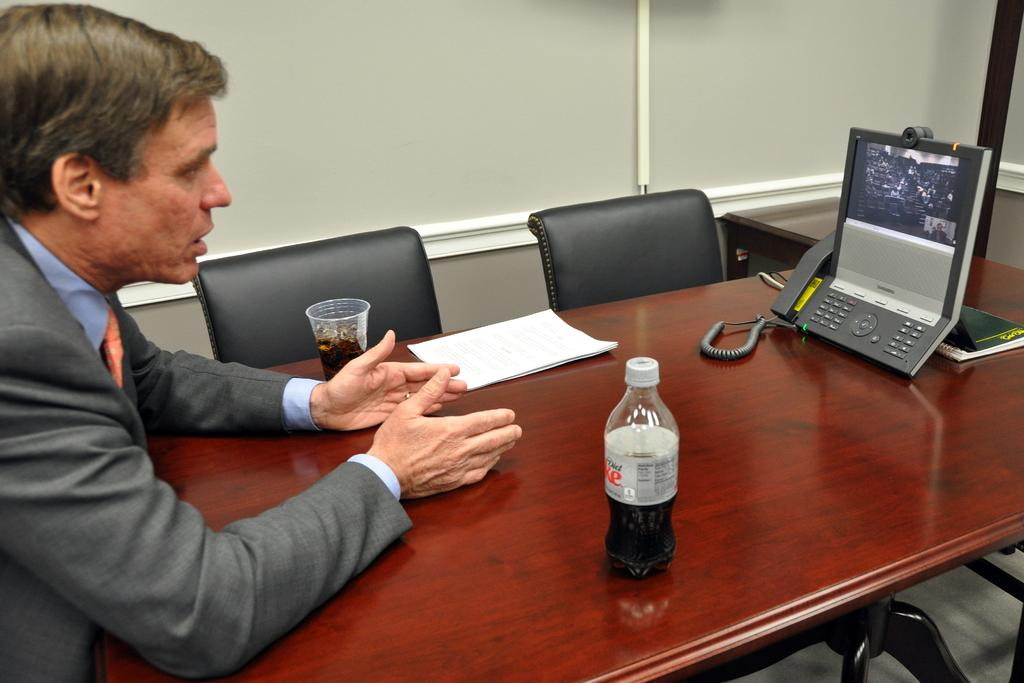What is the person in the image doing? The person is standing in front of the table. What objects are on the table? The table contains a telephone, a bottle, a glass, and a paper. What is the purpose of the telephone on the table? The telephone is likely for communication purposes. What is the purpose of the chairs in front of the wall? The chairs are likely for sitting or providing seating. What type of force is being applied to the paint on the wall in the image? There is no paint or force present in the image. 